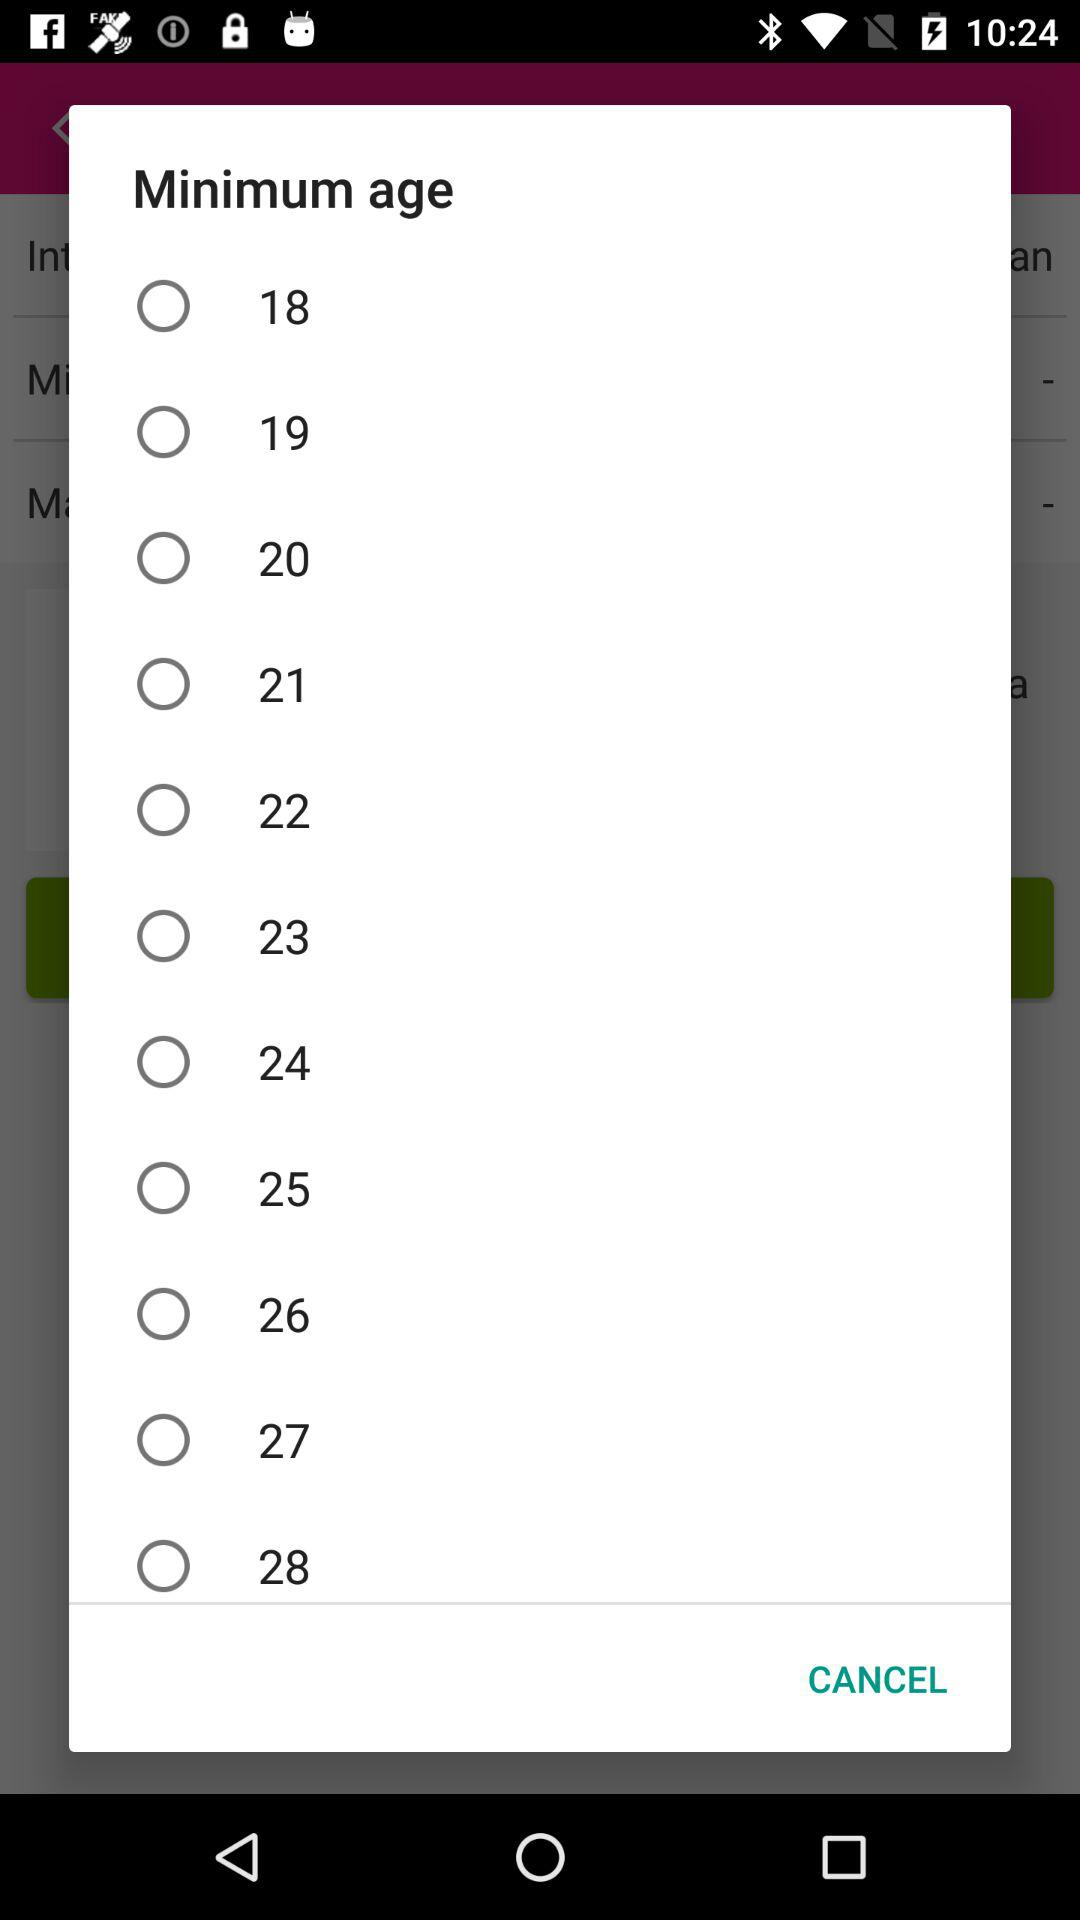What's the given option in "Minimum age"? The given options are 18, 19, 20, 21, 22, 23, 24, 25, 26, 27 and 28. 